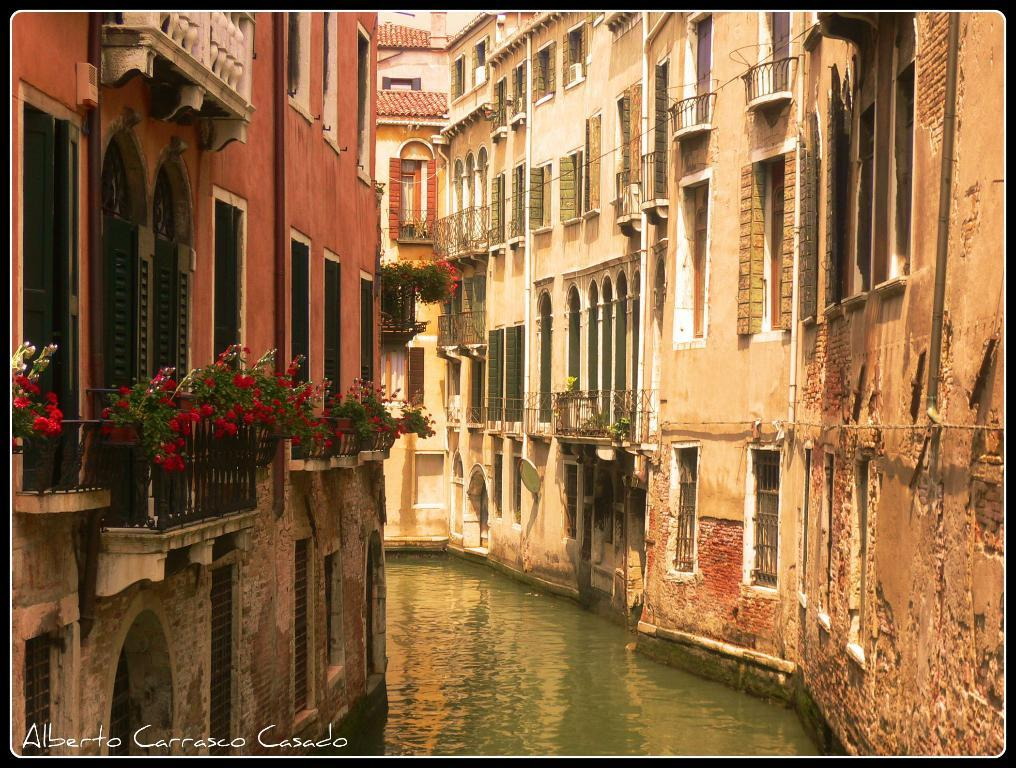What is the primary element in the image? There is water in the image. What type of structures can be seen in the image? There are buildings in the image. What type of plants are present in the image? There are houseplants with flowers in the image. Can you describe any objects in the image? There are some objects in the image. What is visible in the bottom left of the image? There is text visible in the bottom left of the image. What type of fruit is being marked by a finger in the image? There is no fruit or finger present in the image. 